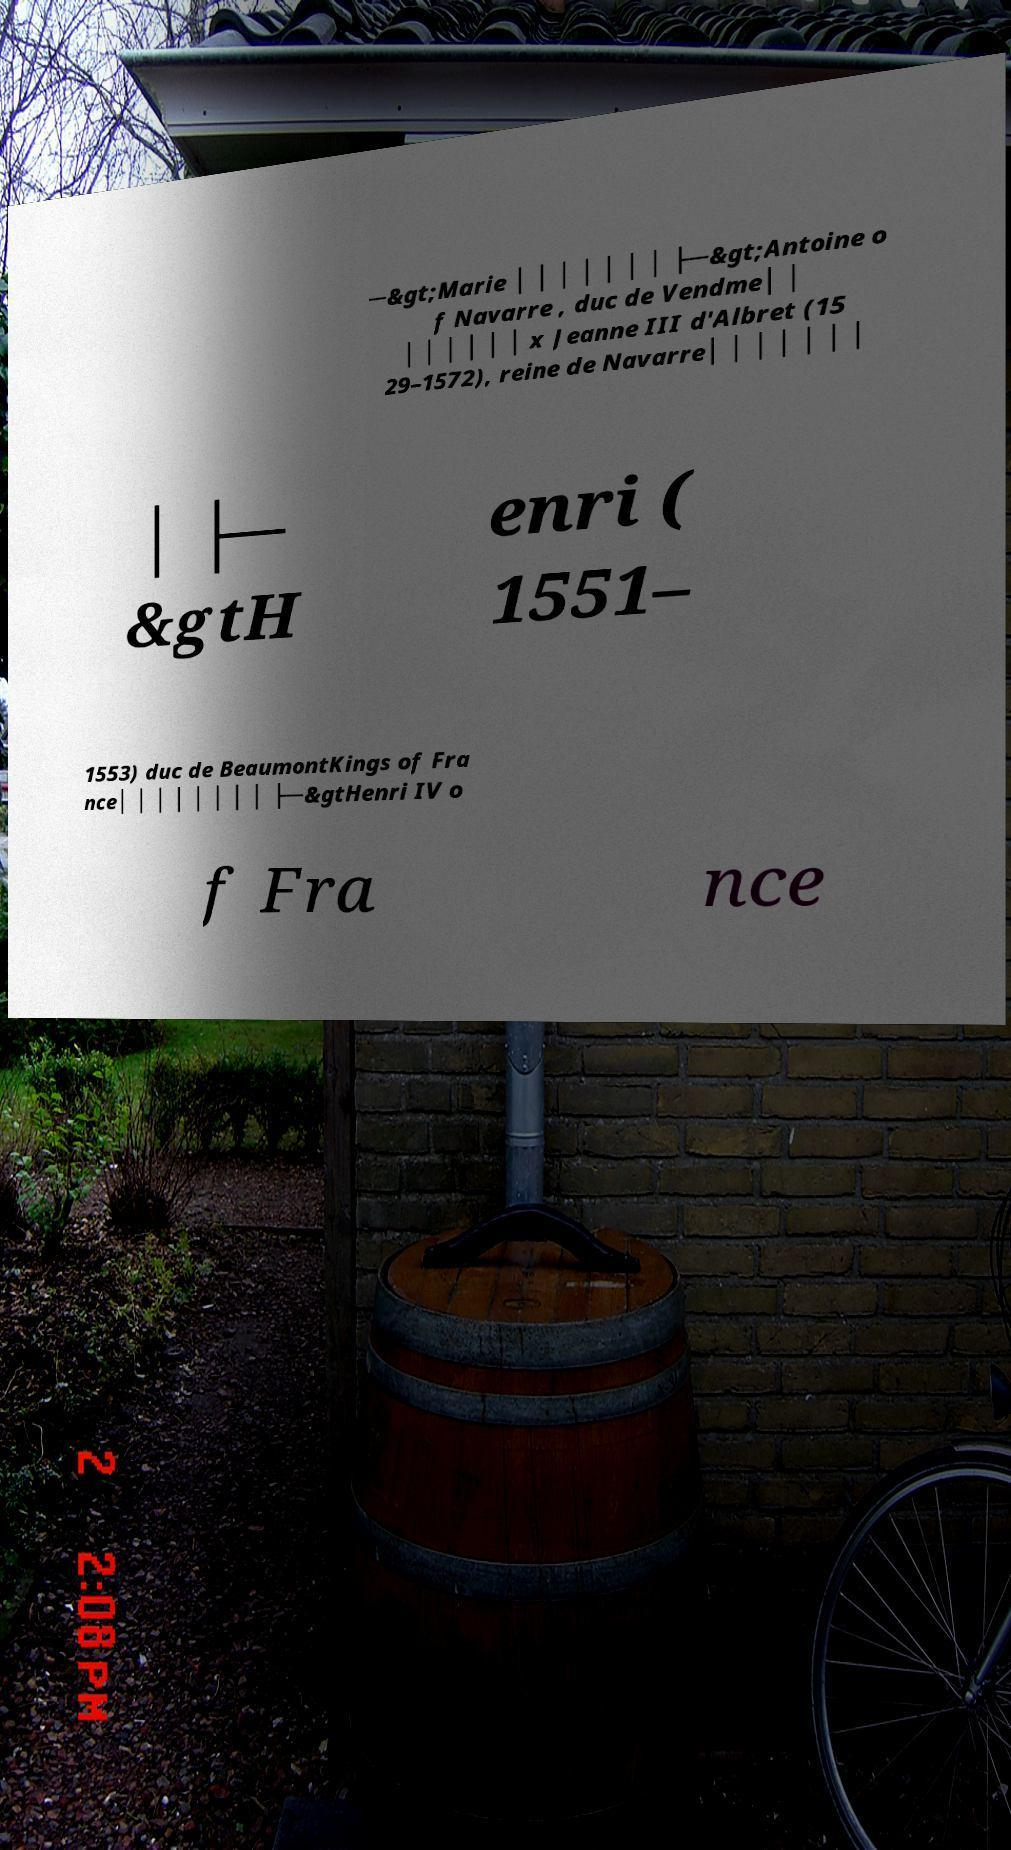Could you assist in decoding the text presented in this image and type it out clearly? ─&gt;Marie │ │ │ │ │ │ │ ├─&gt;Antoine o f Navarre , duc de Vendme│ │ │ │ │ │ │ │ x Jeanne III d'Albret (15 29–1572), reine de Navarre│ │ │ │ │ │ │ │ ├─ &gtH enri ( 1551– 1553) duc de BeaumontKings of Fra nce│ │ │ │ │ │ │ │ ├─&gtHenri IV o f Fra nce 